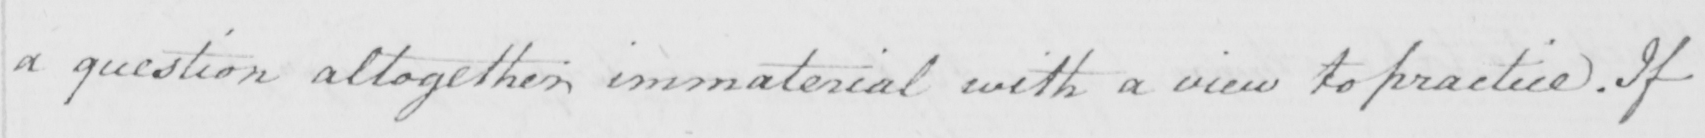What does this handwritten line say? a question altogether immaterial with a view to practice . If 